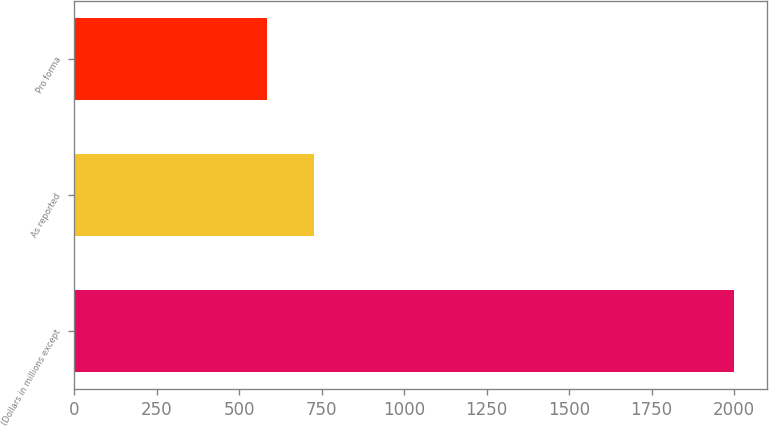Convert chart to OTSL. <chart><loc_0><loc_0><loc_500><loc_500><bar_chart><fcel>(Dollars in millions except<fcel>As reported<fcel>Pro forma<nl><fcel>2001<fcel>726.6<fcel>585<nl></chart> 